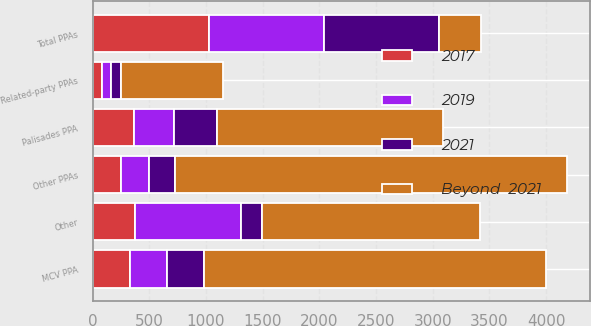<chart> <loc_0><loc_0><loc_500><loc_500><stacked_bar_chart><ecel><fcel>Total PPAs<fcel>Other<fcel>MCV PPA<fcel>Palisades PPA<fcel>Related-party PPAs<fcel>Other PPAs<nl><fcel>Beyond  2021<fcel>365<fcel>1922<fcel>3010<fcel>1994<fcel>899<fcel>3453<nl><fcel>2019<fcel>1008<fcel>931<fcel>326<fcel>354<fcel>81<fcel>247<nl><fcel>2017<fcel>1031<fcel>376<fcel>331<fcel>365<fcel>82<fcel>253<nl><fcel>2021<fcel>1021<fcel>187<fcel>330<fcel>376<fcel>86<fcel>229<nl></chart> 